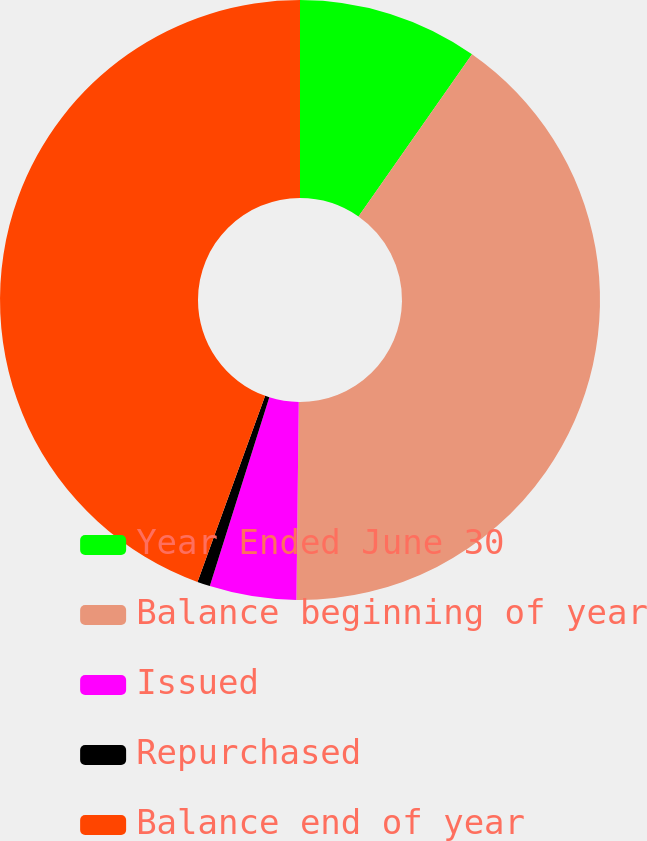Convert chart to OTSL. <chart><loc_0><loc_0><loc_500><loc_500><pie_chart><fcel>Year Ended June 30<fcel>Balance beginning of year<fcel>Issued<fcel>Repurchased<fcel>Balance end of year<nl><fcel>9.72%<fcel>40.47%<fcel>4.67%<fcel>0.69%<fcel>44.45%<nl></chart> 